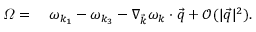<formula> <loc_0><loc_0><loc_500><loc_500>\begin{array} { r l } { \varOmega = \, } & \omega _ { k _ { 1 } } - \omega _ { k _ { 3 } } - \nabla _ { \vec { k } } \omega _ { k } \cdot \vec { q } + \mathcal { O } ( | \vec { q } | ^ { 2 } ) . } \end{array}</formula> 